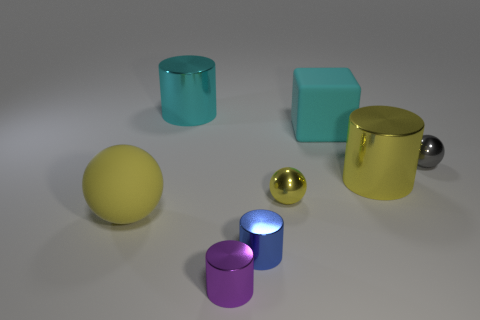Subtract all yellow spheres. How many spheres are left? 1 Subtract 3 cylinders. How many cylinders are left? 1 Add 1 large yellow metallic cylinders. How many objects exist? 9 Subtract all gray balls. How many balls are left? 2 Subtract all cubes. How many objects are left? 7 Subtract all green blocks. Subtract all cyan cylinders. How many blocks are left? 1 Subtract all green balls. How many purple cylinders are left? 1 Subtract all big rubber spheres. Subtract all large cyan cylinders. How many objects are left? 6 Add 5 tiny blue metal cylinders. How many tiny blue metal cylinders are left? 6 Add 2 large green metallic balls. How many large green metallic balls exist? 2 